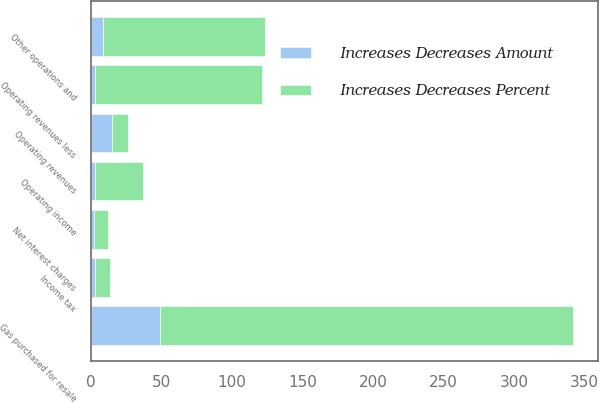Convert chart. <chart><loc_0><loc_0><loc_500><loc_500><stacked_bar_chart><ecel><fcel>Operating revenues<fcel>Gas purchased for resale<fcel>Operating revenues less<fcel>Other operations and<fcel>Income tax<fcel>Operating income<fcel>Net interest charges<nl><fcel>Increases Decreases Percent<fcel>11<fcel>293<fcel>119<fcel>115<fcel>11<fcel>34<fcel>10<nl><fcel>Increases Decreases Amount<fcel>15.4<fcel>49.2<fcel>2.7<fcel>8.7<fcel>2.7<fcel>3.2<fcel>2.3<nl></chart> 